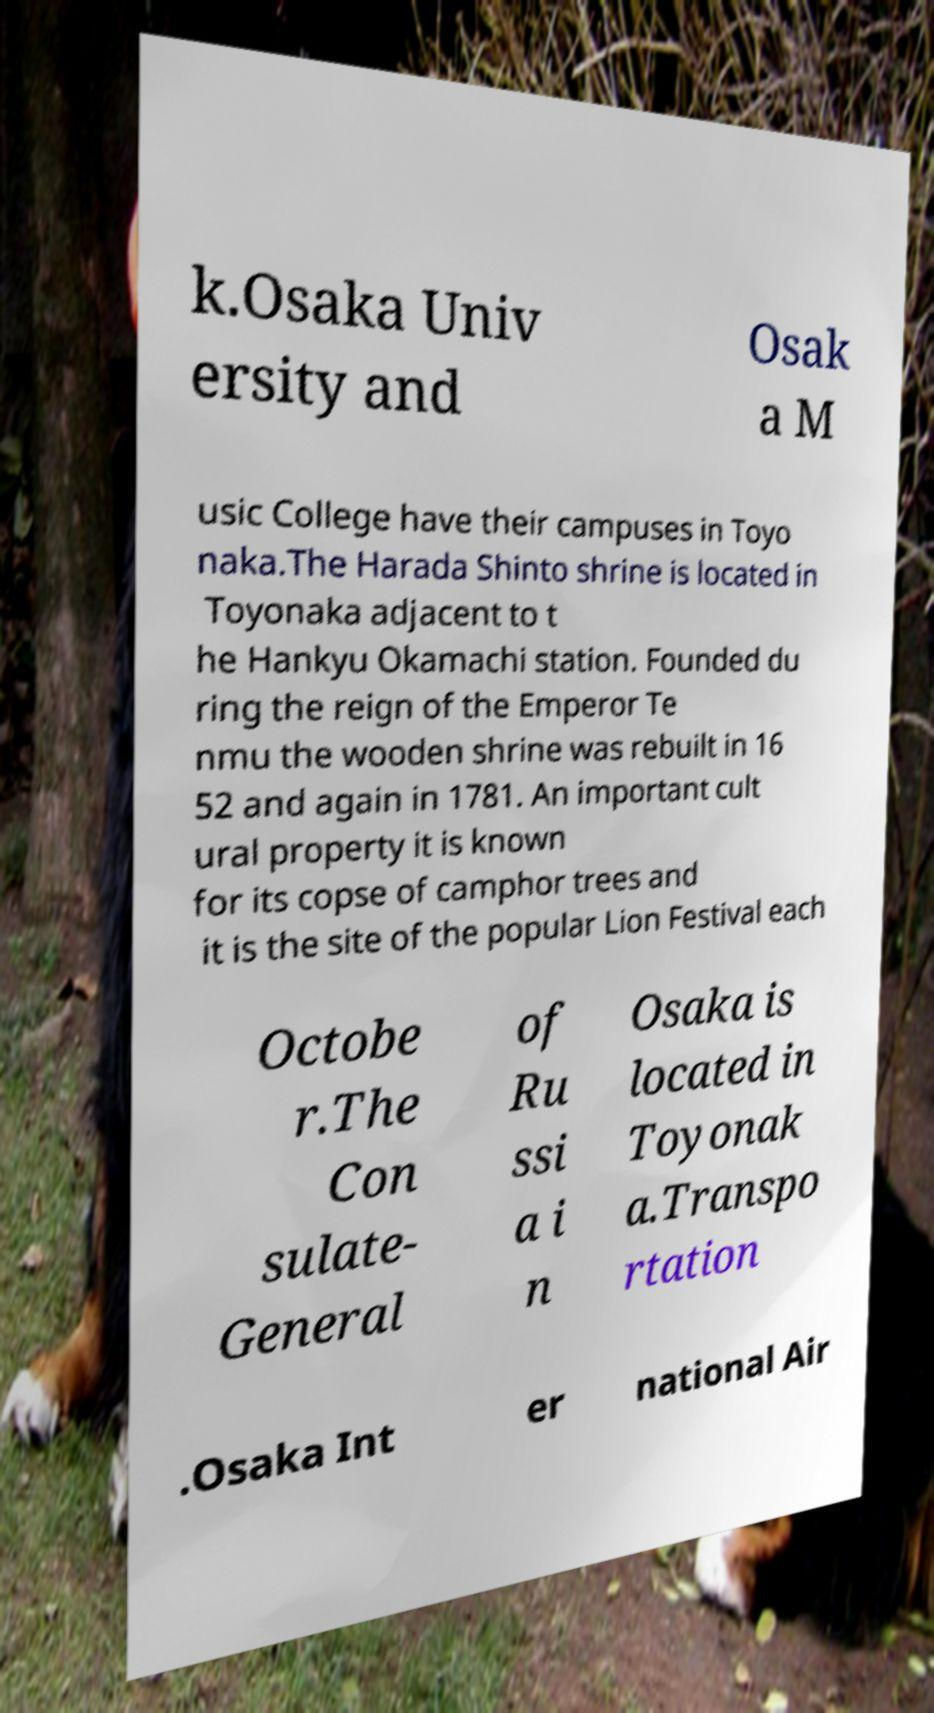I need the written content from this picture converted into text. Can you do that? k.Osaka Univ ersity and Osak a M usic College have their campuses in Toyo naka.The Harada Shinto shrine is located in Toyonaka adjacent to t he Hankyu Okamachi station. Founded du ring the reign of the Emperor Te nmu the wooden shrine was rebuilt in 16 52 and again in 1781. An important cult ural property it is known for its copse of camphor trees and it is the site of the popular Lion Festival each Octobe r.The Con sulate- General of Ru ssi a i n Osaka is located in Toyonak a.Transpo rtation .Osaka Int er national Air 